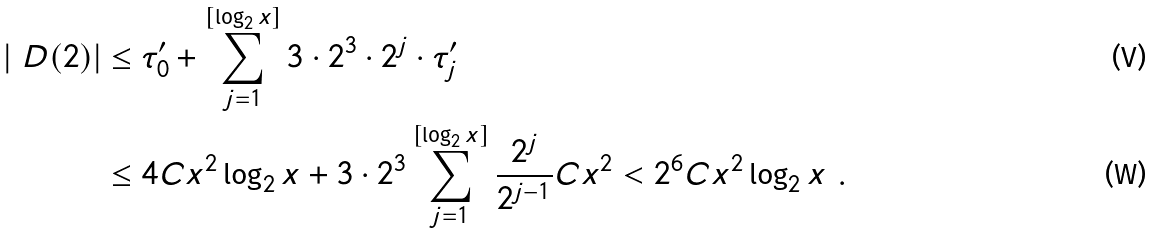<formula> <loc_0><loc_0><loc_500><loc_500>| \ D ( 2 ) | & \leq \tau ^ { \prime } _ { 0 } + \sum _ { j = 1 } ^ { [ \log _ { 2 } x ] } 3 \cdot 2 ^ { 3 } \cdot 2 ^ { j } \cdot \tau ^ { \prime } _ { j } \\ & \leq 4 C x ^ { 2 } \log _ { 2 } x + 3 \cdot 2 ^ { 3 } \sum _ { j = 1 } ^ { [ \log _ { 2 } x ] } \frac { 2 ^ { j } } { 2 ^ { j - 1 } } C x ^ { 2 } < 2 ^ { 6 } C x ^ { 2 } \log _ { 2 } x \ .</formula> 